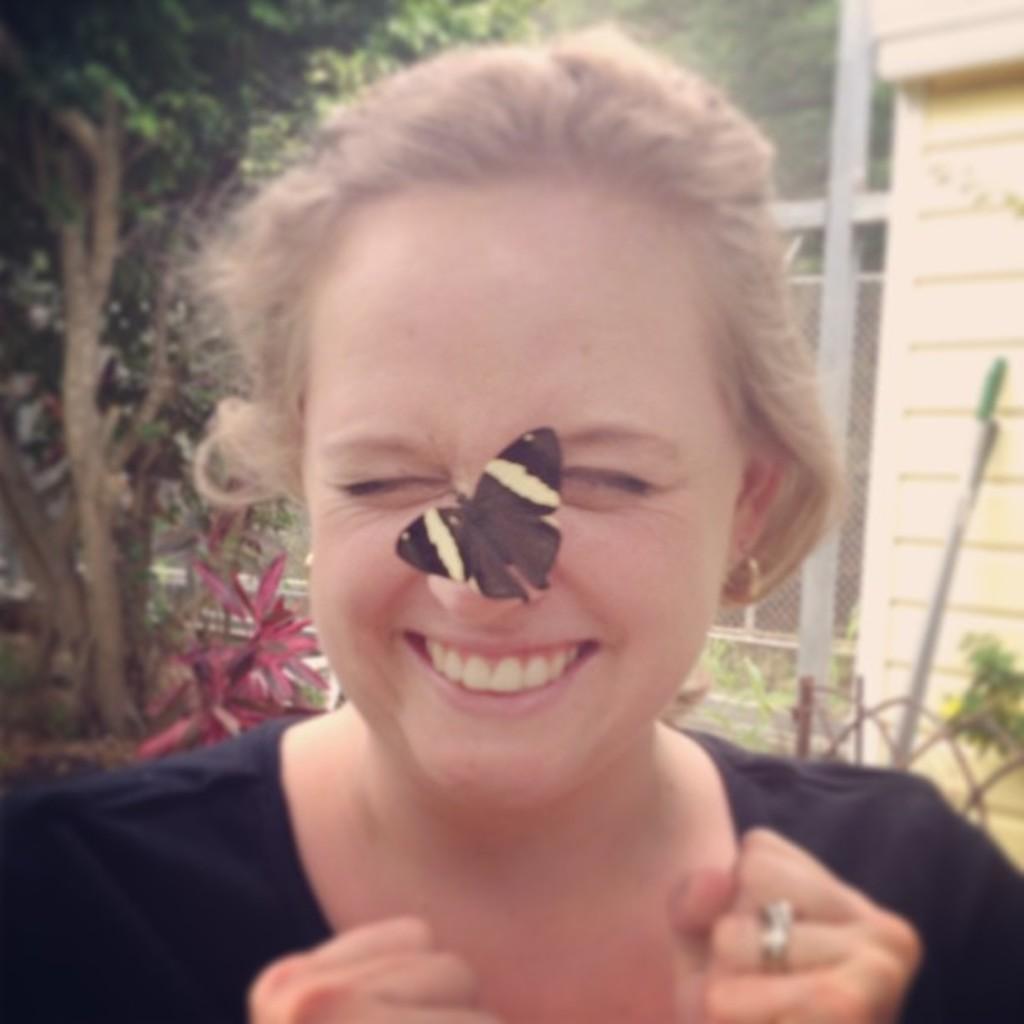Can you describe this image briefly? A person is standing wearing a black t shirt. There is a butterfly on her nose. Behind her there are trees, fencing and a building. 